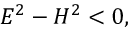Convert formula to latex. <formula><loc_0><loc_0><loc_500><loc_500>E ^ { 2 } - H ^ { 2 } < 0 ,</formula> 